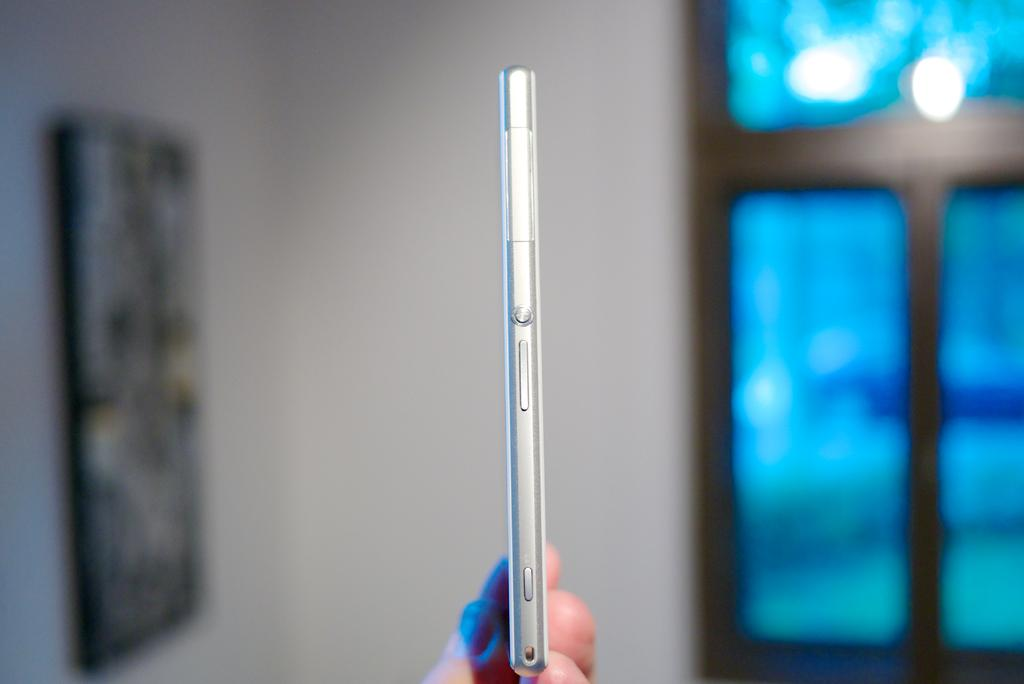What is the main object in the center of the image? There is a phone in the center of the image. What can be seen on the left side of the image? There is a portrait on the left side of the image. What is located on the right side of the image? There is a window on the right side of the image. What type of twig can be seen in the aftermath of the expert's visit in the image? There is no twig, aftermath, or expert present in the image. 